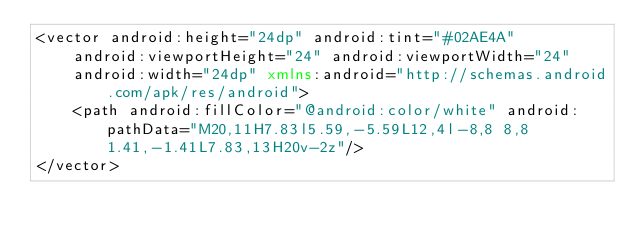<code> <loc_0><loc_0><loc_500><loc_500><_XML_><vector android:height="24dp" android:tint="#02AE4A"
    android:viewportHeight="24" android:viewportWidth="24"
    android:width="24dp" xmlns:android="http://schemas.android.com/apk/res/android">
    <path android:fillColor="@android:color/white" android:pathData="M20,11H7.83l5.59,-5.59L12,4l-8,8 8,8 1.41,-1.41L7.83,13H20v-2z"/>
</vector>
</code> 